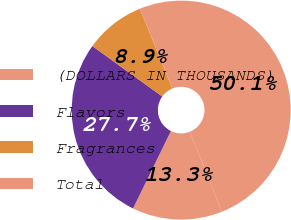<chart> <loc_0><loc_0><loc_500><loc_500><pie_chart><fcel>(DOLLARS IN THOUSANDS)<fcel>Flavors<fcel>Fragrances<fcel>Total<nl><fcel>13.3%<fcel>27.7%<fcel>8.89%<fcel>50.11%<nl></chart> 